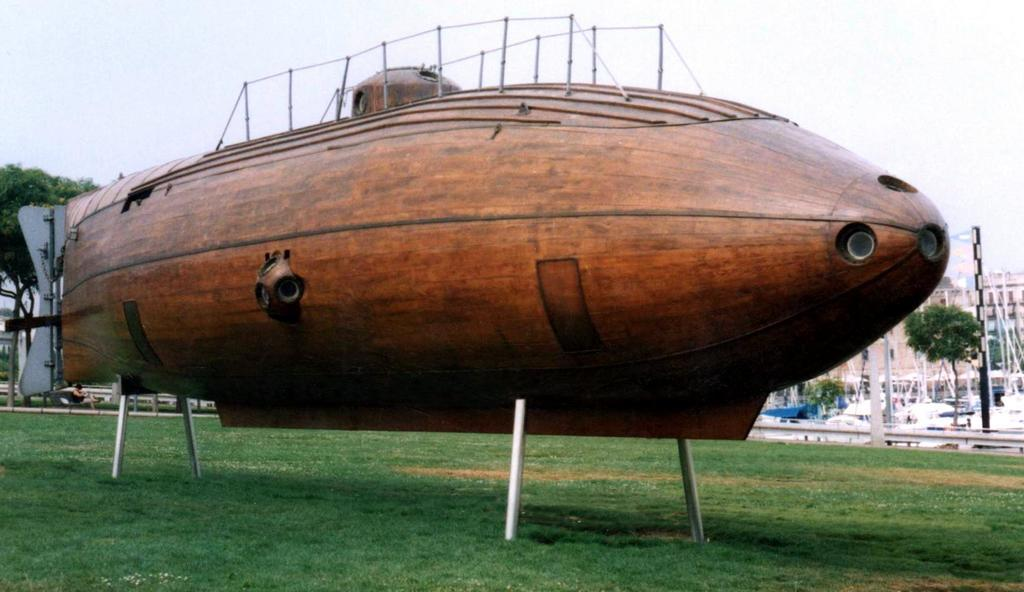What is the main subject of the picture? The main subject of the picture is a submarine. What can be seen in the backdrop of the picture? In the backdrop of the picture, there are boats, trees, and buildings. How is the sky depicted in the picture? The sky is clear in the picture. How many bears are visible on the submarine in the image? There are no bears present on the submarine or in the image. What type of power source is used by the submarine in the image? The image does not provide information about the power source of the submarine. 